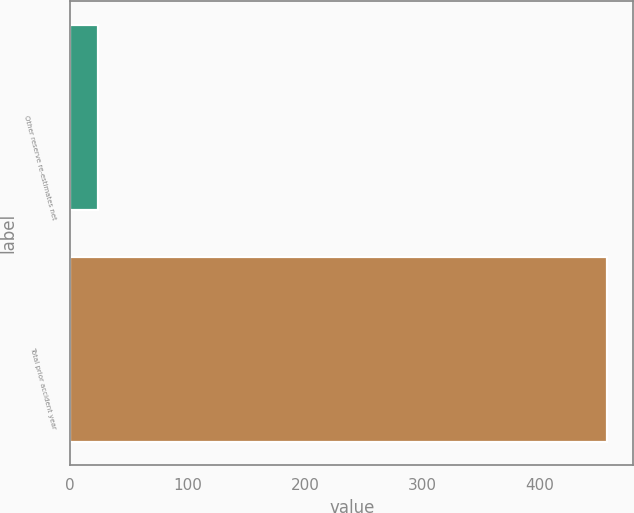<chart> <loc_0><loc_0><loc_500><loc_500><bar_chart><fcel>Other reserve re-estimates net<fcel>Total prior accident year<nl><fcel>24<fcel>457<nl></chart> 